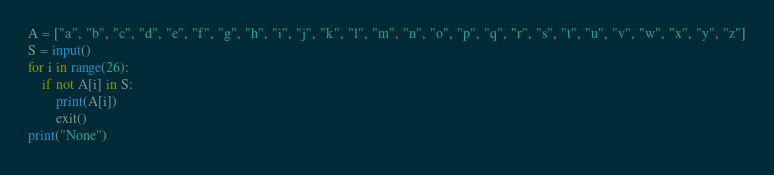<code> <loc_0><loc_0><loc_500><loc_500><_Python_>A = ["a", "b", "c", "d", "e", "f", "g", "h", "i", "j", "k", "l", "m", "n", "o", "p", "q", "r", "s", "t", "u", "v", "w", "x", "y", "z"]
S = input()
for i in range(26):
	if not A[i] in S:
		print(A[i])
		exit()
print("None")
</code> 